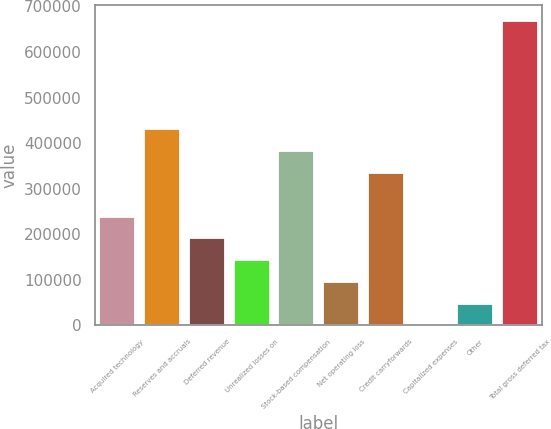Convert chart to OTSL. <chart><loc_0><loc_0><loc_500><loc_500><bar_chart><fcel>Acquired technology<fcel>Reserves and accruals<fcel>Deferred revenue<fcel>Unrealized losses on<fcel>Stock-based compensation<fcel>Net operating loss<fcel>Credit carryforwards<fcel>Capitalized expenses<fcel>Other<fcel>Total gross deferred tax<nl><fcel>238921<fcel>429907<fcel>191174<fcel>143428<fcel>382161<fcel>95681.2<fcel>334414<fcel>188<fcel>47934.6<fcel>668640<nl></chart> 